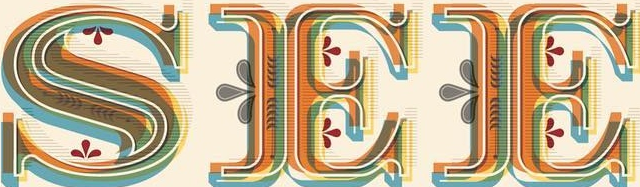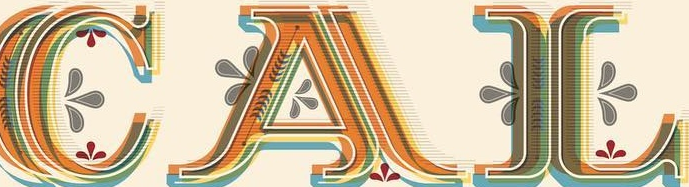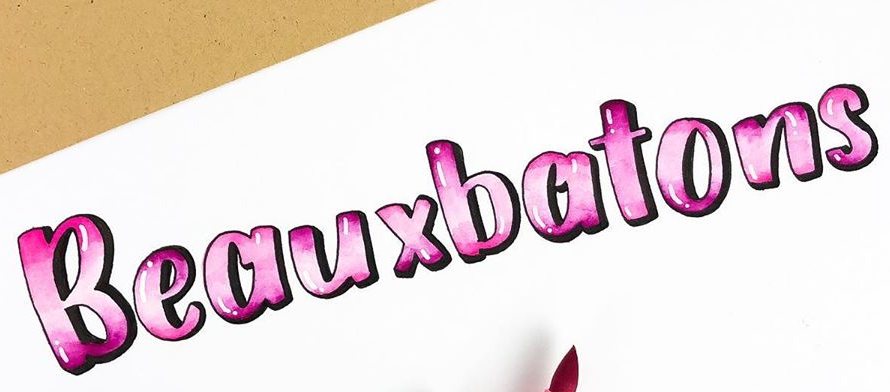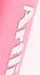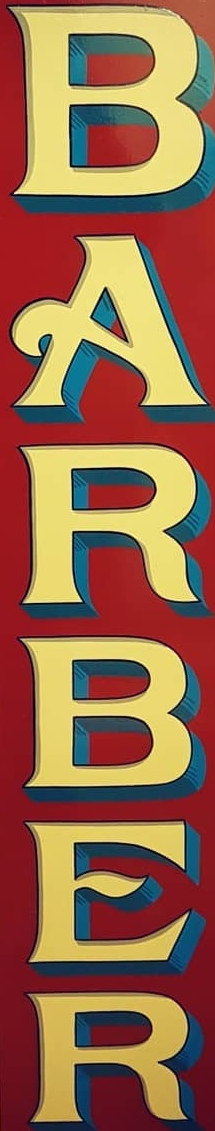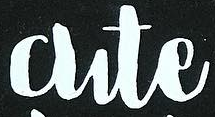Identify the words shown in these images in order, separated by a semicolon. SEE; CAL; Beauxbatons; Artli; BARBER; Cute 